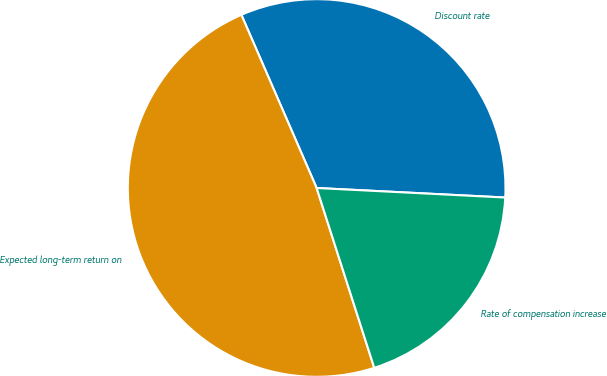Convert chart. <chart><loc_0><loc_0><loc_500><loc_500><pie_chart><fcel>Discount rate<fcel>Expected long-term return on<fcel>Rate of compensation increase<nl><fcel>32.33%<fcel>48.41%<fcel>19.26%<nl></chart> 